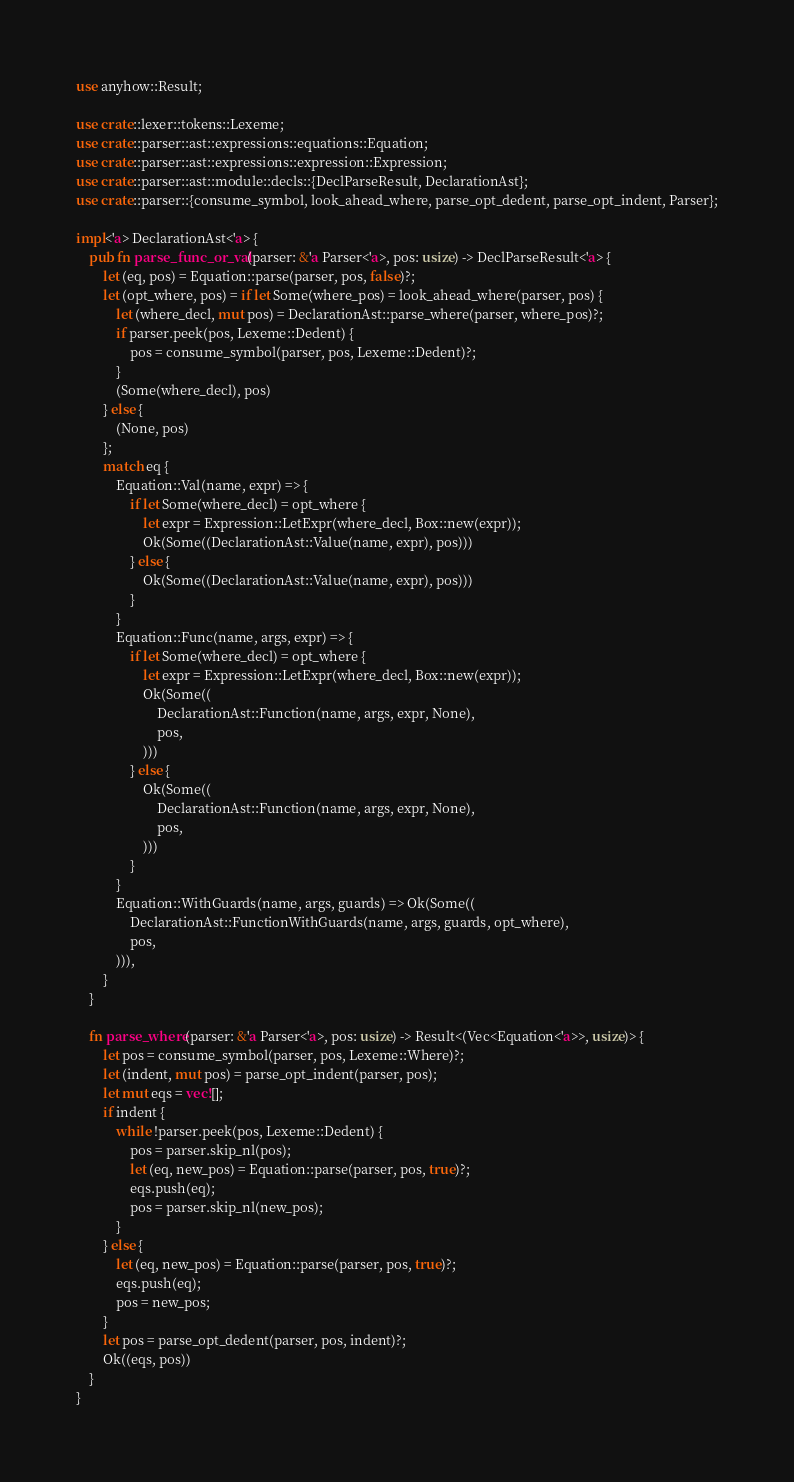<code> <loc_0><loc_0><loc_500><loc_500><_Rust_>use anyhow::Result;

use crate::lexer::tokens::Lexeme;
use crate::parser::ast::expressions::equations::Equation;
use crate::parser::ast::expressions::expression::Expression;
use crate::parser::ast::module::decls::{DeclParseResult, DeclarationAst};
use crate::parser::{consume_symbol, look_ahead_where, parse_opt_dedent, parse_opt_indent, Parser};

impl<'a> DeclarationAst<'a> {
    pub fn parse_func_or_val(parser: &'a Parser<'a>, pos: usize) -> DeclParseResult<'a> {
        let (eq, pos) = Equation::parse(parser, pos, false)?;
        let (opt_where, pos) = if let Some(where_pos) = look_ahead_where(parser, pos) {
            let (where_decl, mut pos) = DeclarationAst::parse_where(parser, where_pos)?;
            if parser.peek(pos, Lexeme::Dedent) {
                pos = consume_symbol(parser, pos, Lexeme::Dedent)?;
            }
            (Some(where_decl), pos)
        } else {
            (None, pos)
        };
        match eq {
            Equation::Val(name, expr) => {
                if let Some(where_decl) = opt_where {
                    let expr = Expression::LetExpr(where_decl, Box::new(expr));
                    Ok(Some((DeclarationAst::Value(name, expr), pos)))
                } else {
                    Ok(Some((DeclarationAst::Value(name, expr), pos)))
                }
            }
            Equation::Func(name, args, expr) => {
                if let Some(where_decl) = opt_where {
                    let expr = Expression::LetExpr(where_decl, Box::new(expr));
                    Ok(Some((
                        DeclarationAst::Function(name, args, expr, None),
                        pos,
                    )))
                } else {
                    Ok(Some((
                        DeclarationAst::Function(name, args, expr, None),
                        pos,
                    )))
                }
            }
            Equation::WithGuards(name, args, guards) => Ok(Some((
                DeclarationAst::FunctionWithGuards(name, args, guards, opt_where),
                pos,
            ))),
        }
    }

    fn parse_where(parser: &'a Parser<'a>, pos: usize) -> Result<(Vec<Equation<'a>>, usize)> {
        let pos = consume_symbol(parser, pos, Lexeme::Where)?;
        let (indent, mut pos) = parse_opt_indent(parser, pos);
        let mut eqs = vec![];
        if indent {
            while !parser.peek(pos, Lexeme::Dedent) {
                pos = parser.skip_nl(pos);
                let (eq, new_pos) = Equation::parse(parser, pos, true)?;
                eqs.push(eq);
                pos = parser.skip_nl(new_pos);
            }
        } else {
            let (eq, new_pos) = Equation::parse(parser, pos, true)?;
            eqs.push(eq);
            pos = new_pos;
        }
        let pos = parse_opt_dedent(parser, pos, indent)?;
        Ok((eqs, pos))
    }
}
</code> 